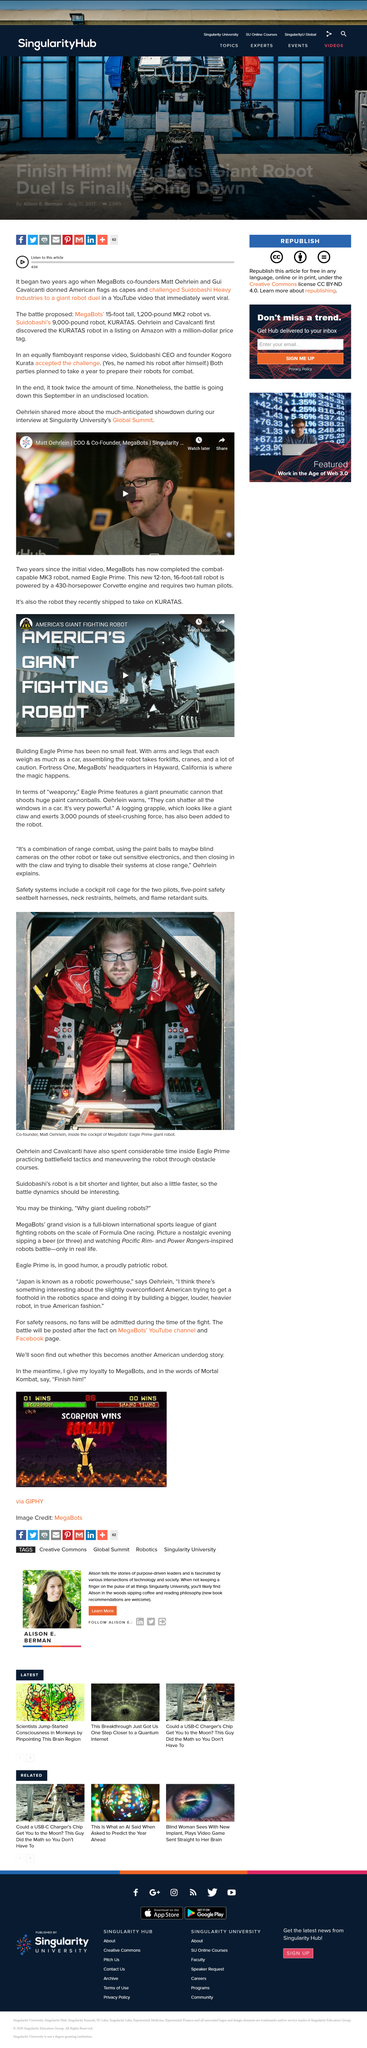Specify some key components in this picture. Paint balls can be used to "blind" other robots by shooting at their cameras, rendering them unable to function properly. I declare that the name of the giant robot is Eagle Prime. The robot's creators have been utilizing it for the purpose of battlefield tactics and navigating obstacle courses. 